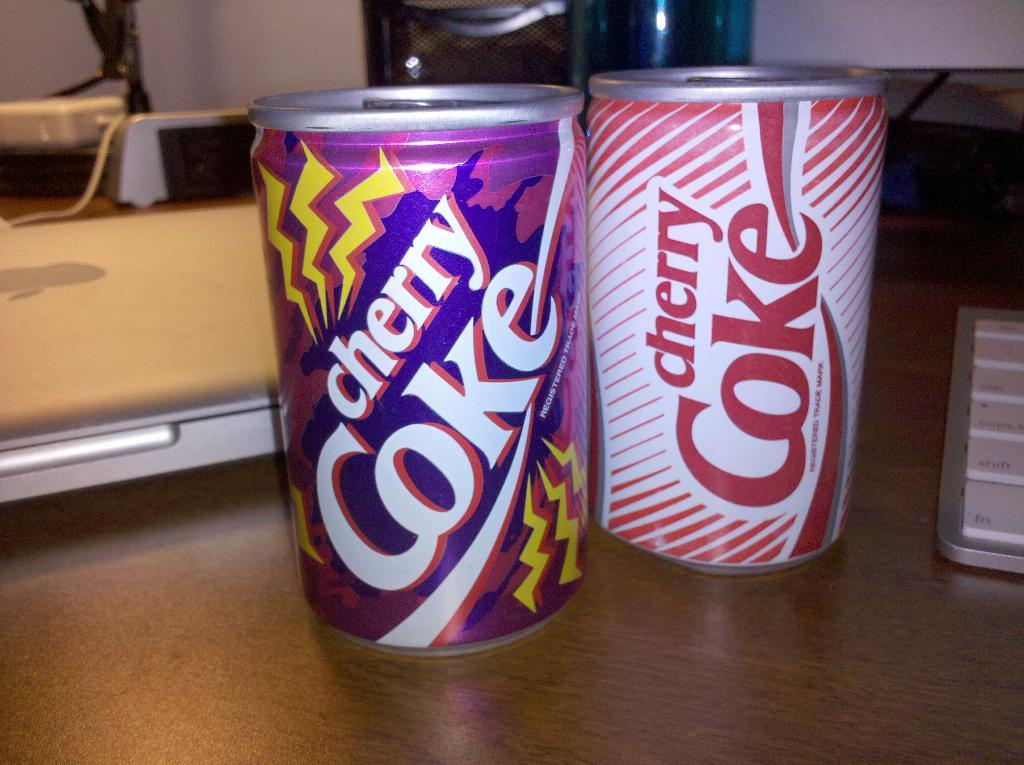<image>
Describe the image concisely. Two cans of Cherry Coke sit on a counter. 